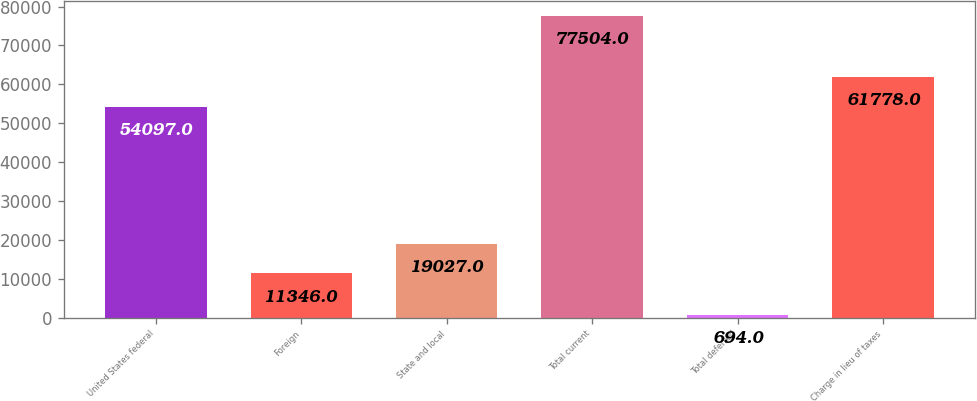Convert chart to OTSL. <chart><loc_0><loc_0><loc_500><loc_500><bar_chart><fcel>United States federal<fcel>Foreign<fcel>State and local<fcel>Total current<fcel>Total deferred<fcel>Charge in lieu of taxes<nl><fcel>54097<fcel>11346<fcel>19027<fcel>77504<fcel>694<fcel>61778<nl></chart> 